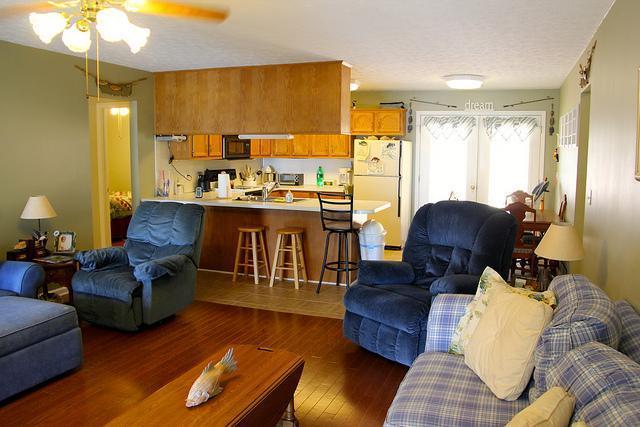How many couches are there?
Give a very brief answer. 2. How many chairs are there?
Give a very brief answer. 3. How many forks are in the picture?
Give a very brief answer. 0. 